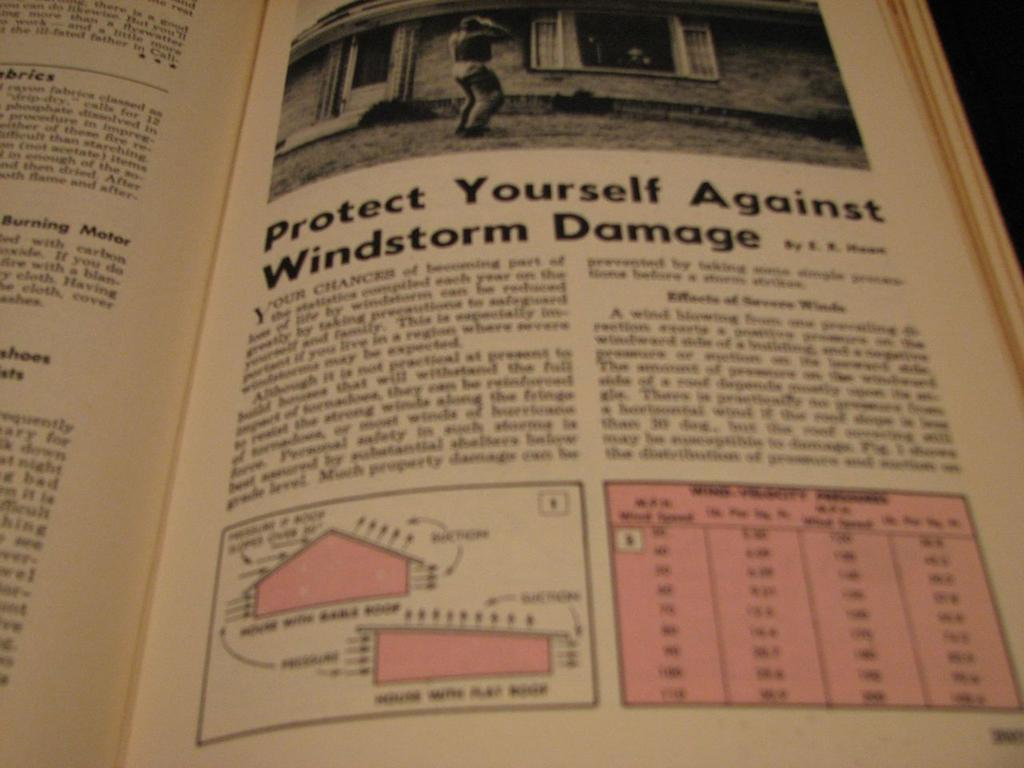<image>
Create a compact narrative representing the image presented. Open book about protecting yourself against windstorm damage. 